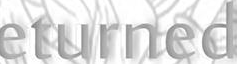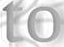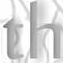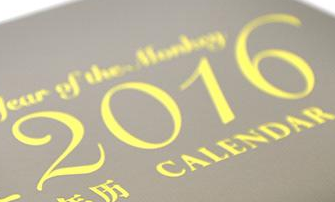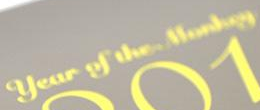What words are shown in these images in order, separated by a semicolon? eturned; to; th; 2016; # 